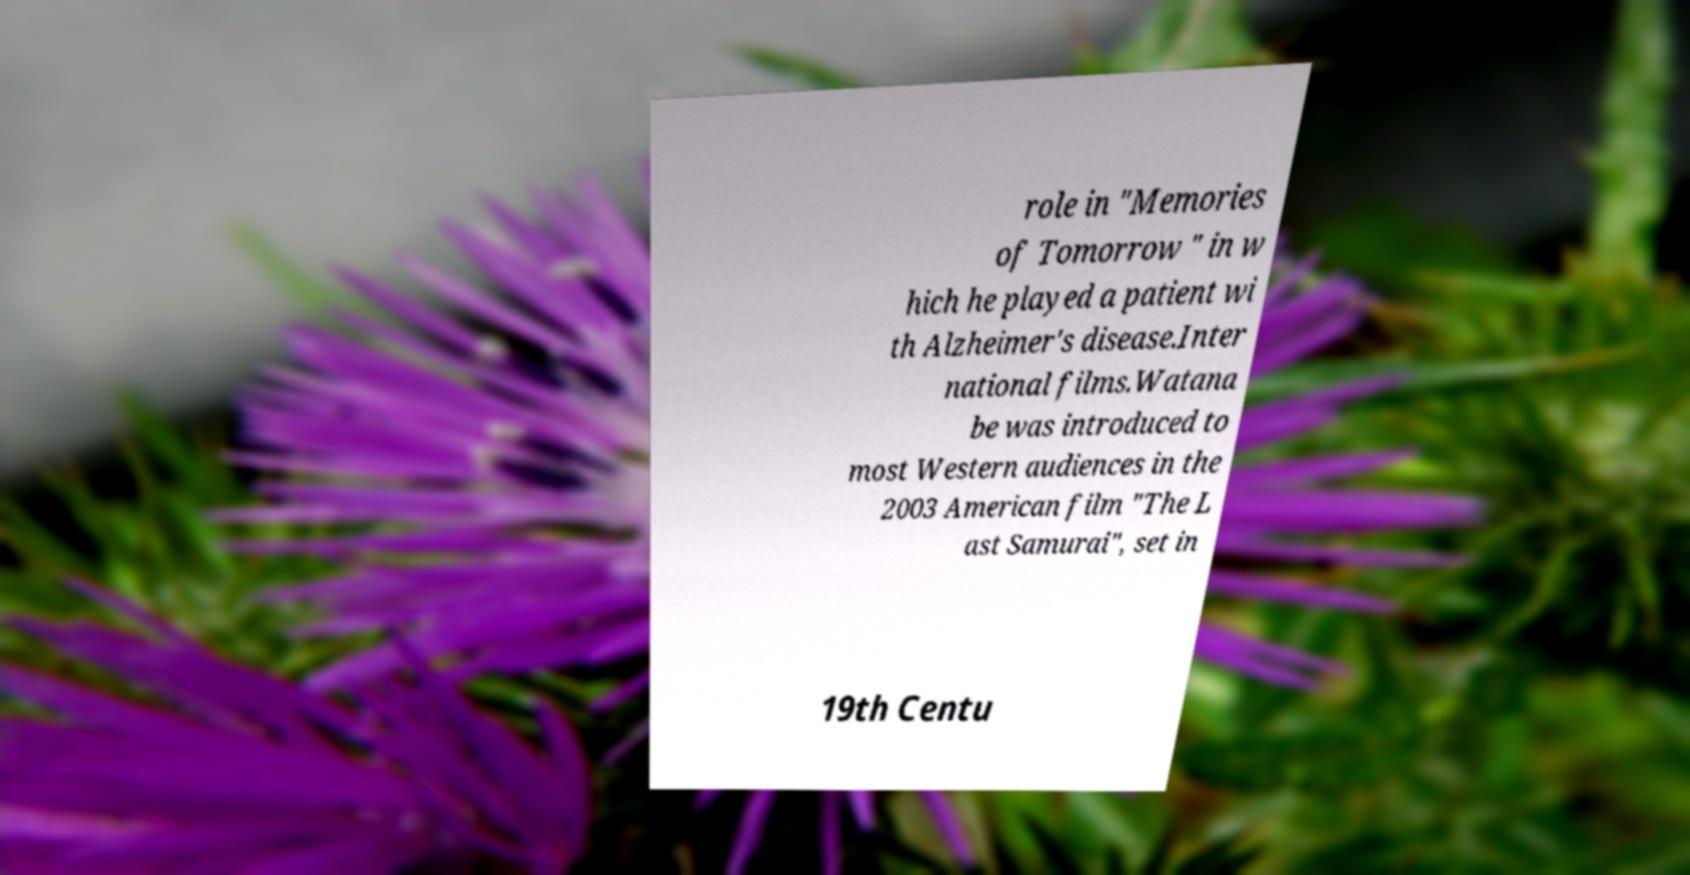Could you assist in decoding the text presented in this image and type it out clearly? role in "Memories of Tomorrow " in w hich he played a patient wi th Alzheimer's disease.Inter national films.Watana be was introduced to most Western audiences in the 2003 American film "The L ast Samurai", set in 19th Centu 